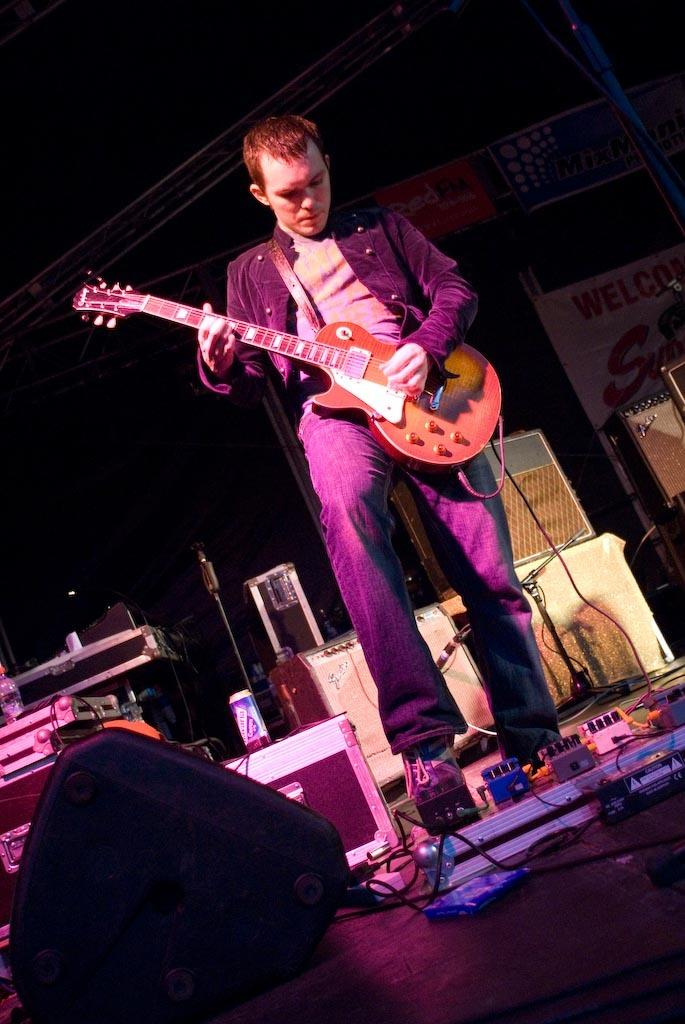What is the man in the image doing? The man is playing a guitar. What type of surface is visible in the image? There is a floor in the image. What other musical instruments can be seen in the image? There are musical instruments in the image, but the specific instruments are not mentioned in the facts. What device is present for amplifying sound or for the man to sing into? There is a microphone (mike) in the image. What is hanging or attached to the ceiling in the image? There is a banner in the image. What vertical structure is present in the image? There is a pole in the image. Can you see any plants or a lake in the image? No, there are no plants or a lake visible in the image. 